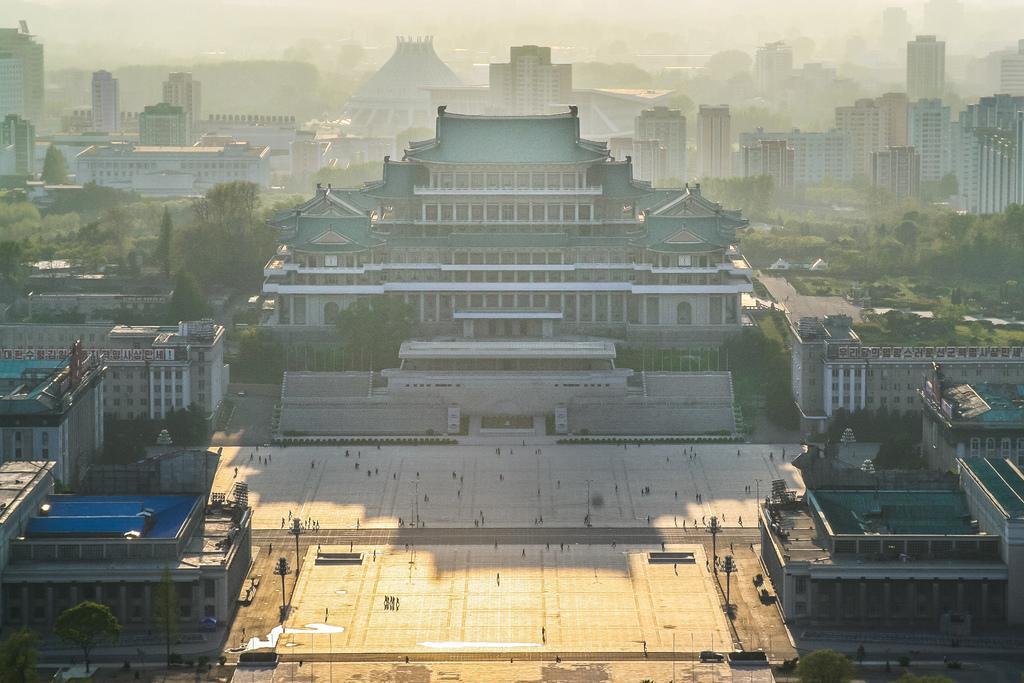Describe this image in one or two sentences. In this image, there are a few buildings. We can see some trees, plants. We can see the ground with some objects. We can see some poles and grass. 